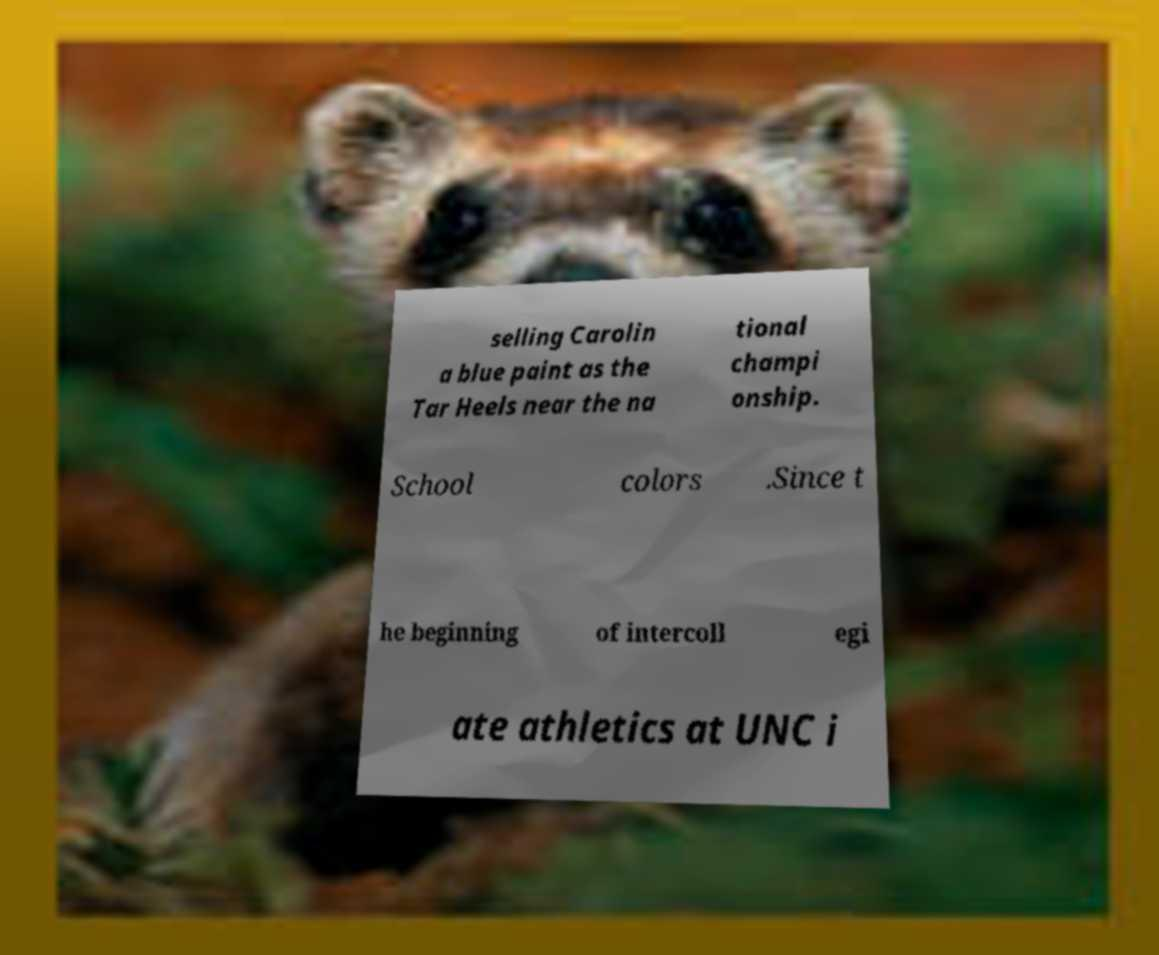There's text embedded in this image that I need extracted. Can you transcribe it verbatim? selling Carolin a blue paint as the Tar Heels near the na tional champi onship. School colors .Since t he beginning of intercoll egi ate athletics at UNC i 